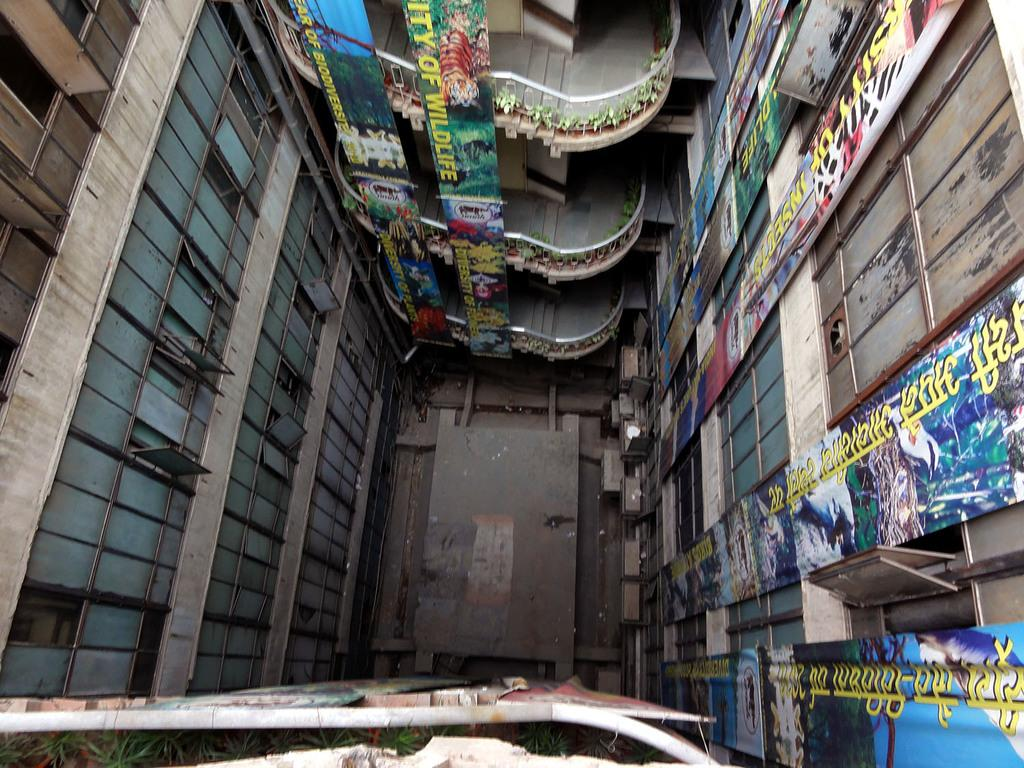What is there is a structure visible in the image, what is it? There is a building in the image. What can be seen on the building? There are banners on the building. What architectural feature is present in the building? There are staircases in the building. What allows natural light to enter the building? There are windows in the building. Can you describe any other objects or features inside the building? There are unspecified objects in the building. What type of pies are being exchanged between the people inside the building? There is no indication of pies or people exchanging anything in the image; it only shows a building with banners, staircases, windows, and unspecified objects. 